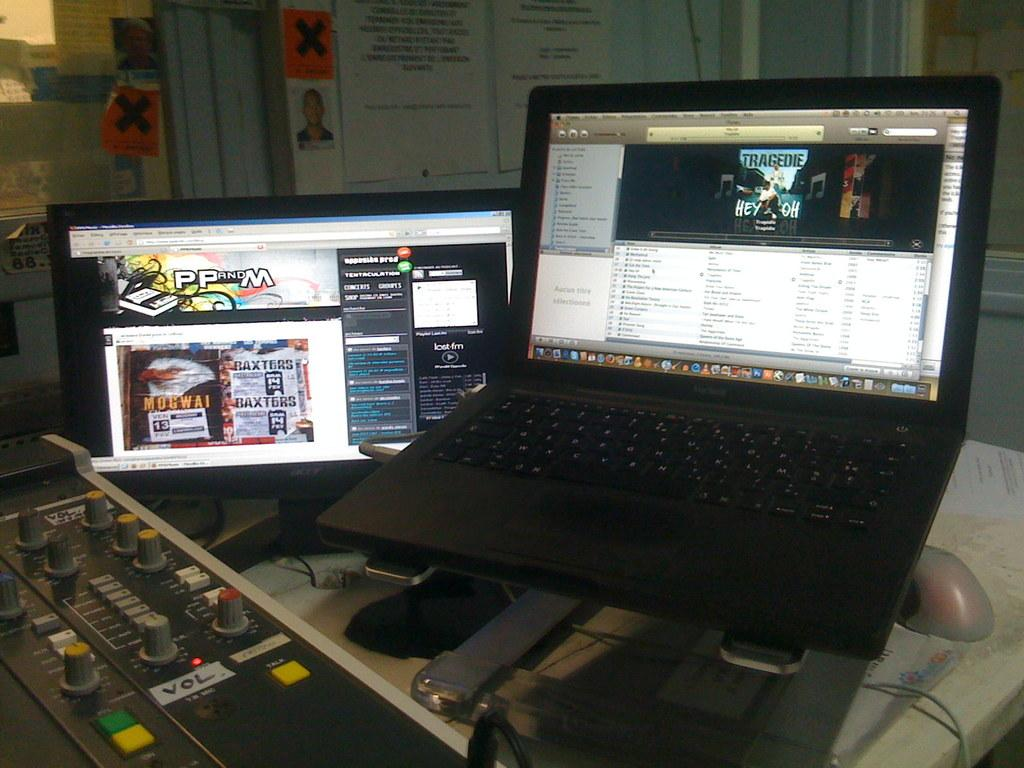<image>
Write a terse but informative summary of the picture. a black macbook open to a music tab 